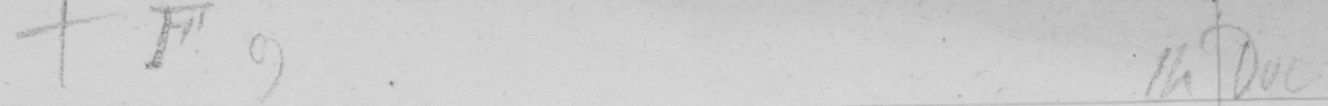What does this handwritten line say? F.9 . 14 Dec 